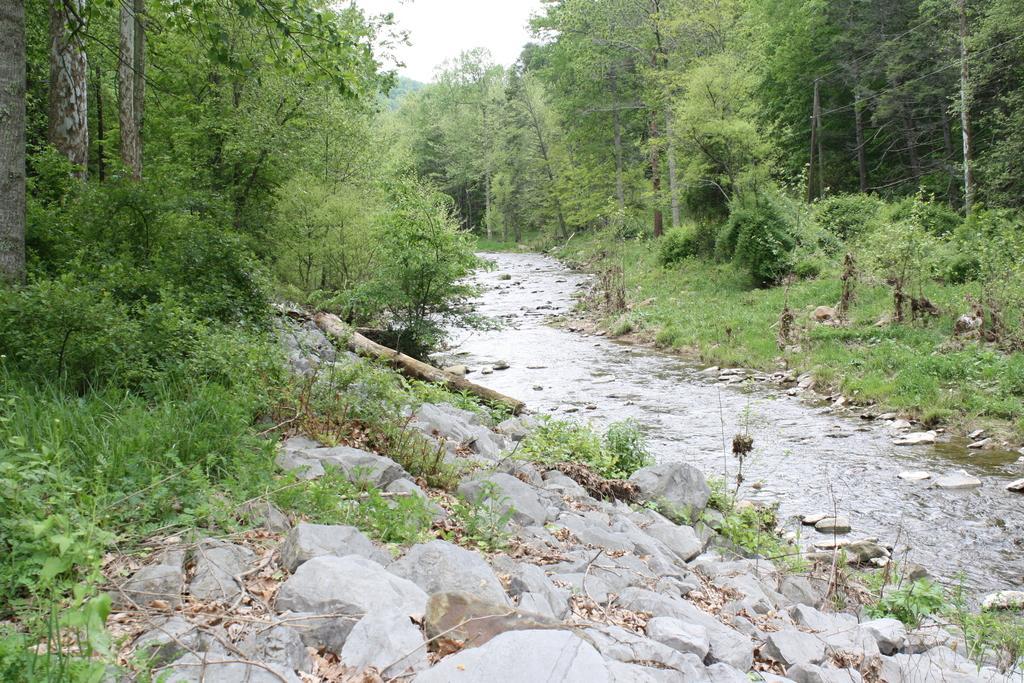Please provide a concise description of this image. At the bottom of the image we can see some stones and water. In the middle of the image we can see some trees and grass. At the top of the image we can see the sky. 